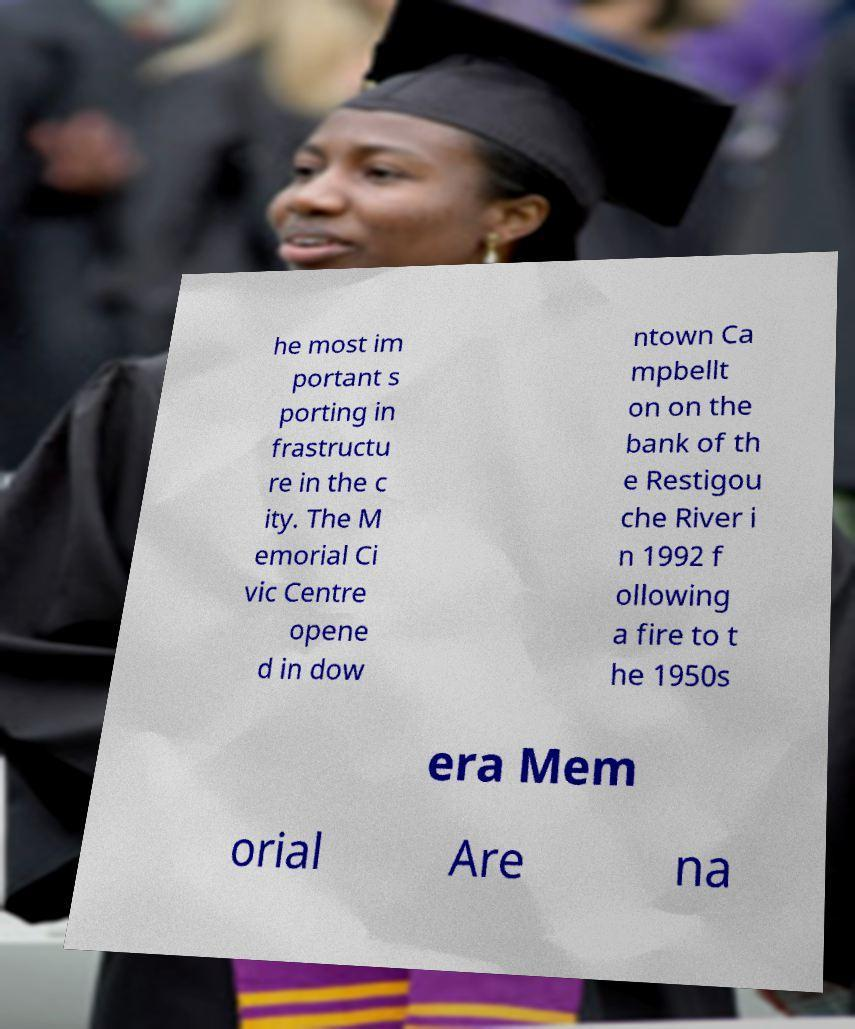I need the written content from this picture converted into text. Can you do that? he most im portant s porting in frastructu re in the c ity. The M emorial Ci vic Centre opene d in dow ntown Ca mpbellt on on the bank of th e Restigou che River i n 1992 f ollowing a fire to t he 1950s era Mem orial Are na 